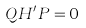<formula> <loc_0><loc_0><loc_500><loc_500>Q H ^ { \prime } P = 0</formula> 